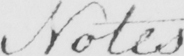What is written in this line of handwriting? Notes . 